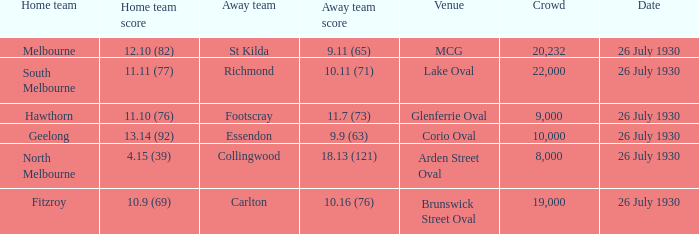Where did Geelong play a home game? Corio Oval. 